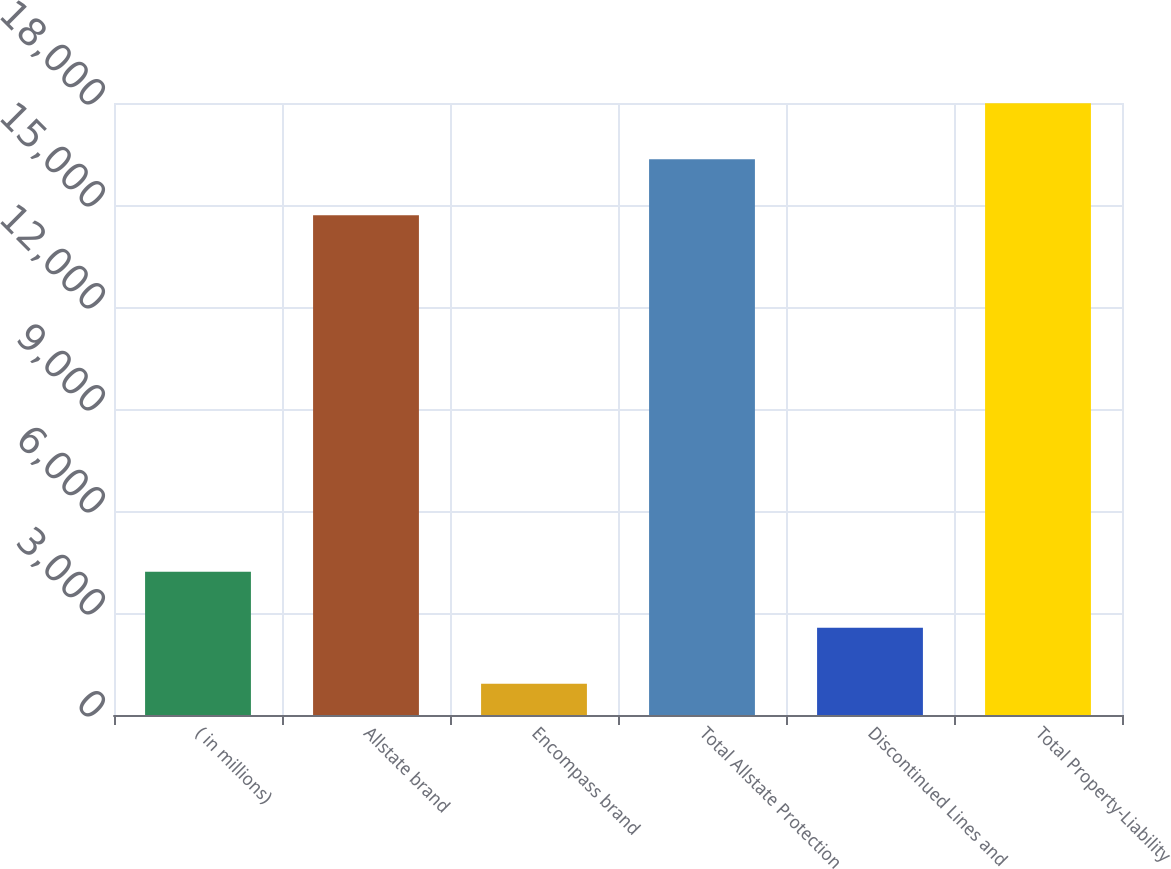<chart> <loc_0><loc_0><loc_500><loc_500><bar_chart><fcel>( in millions)<fcel>Allstate brand<fcel>Encompass brand<fcel>Total Allstate Protection<fcel>Discontinued Lines and<fcel>Total Property-Liability<nl><fcel>4216<fcel>14696<fcel>921<fcel>16343.5<fcel>2568.5<fcel>17991<nl></chart> 